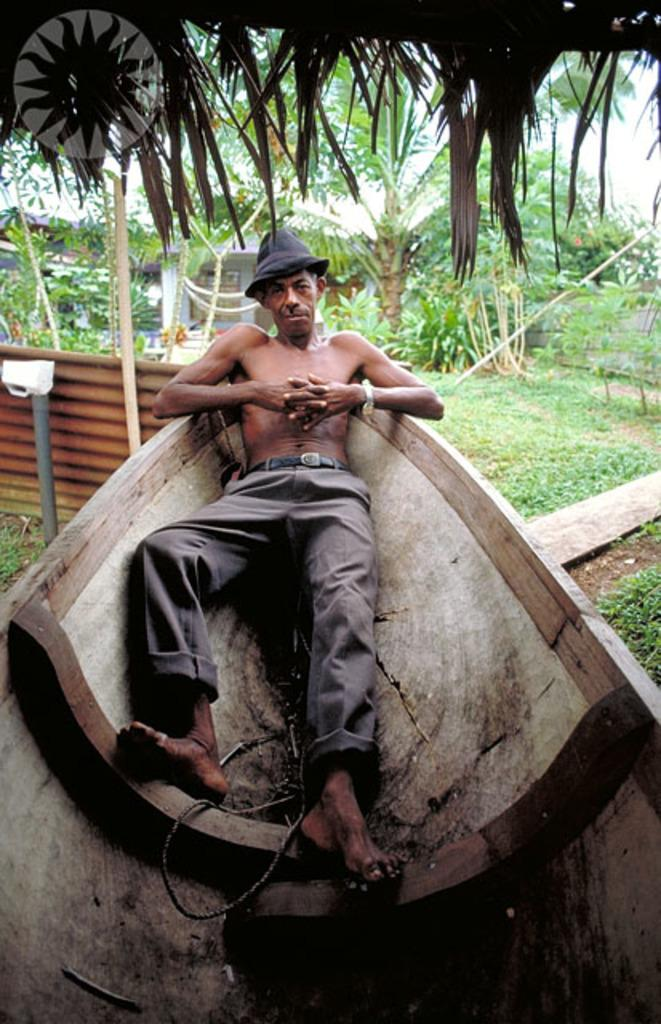Who or what is in the image? There is a person in the image. What is the person doing in the image? The person is laying on a boat. Where is the boat located in the image? The boat is on a grass surface. What can be seen in the background of the image? There are trees behind the boat. What type of comb is the person using to style their hair in the image? There is no comb visible in the image, and the person's hair is not mentioned in the provided facts, so we cannot determine if the person is using a comb or not. 